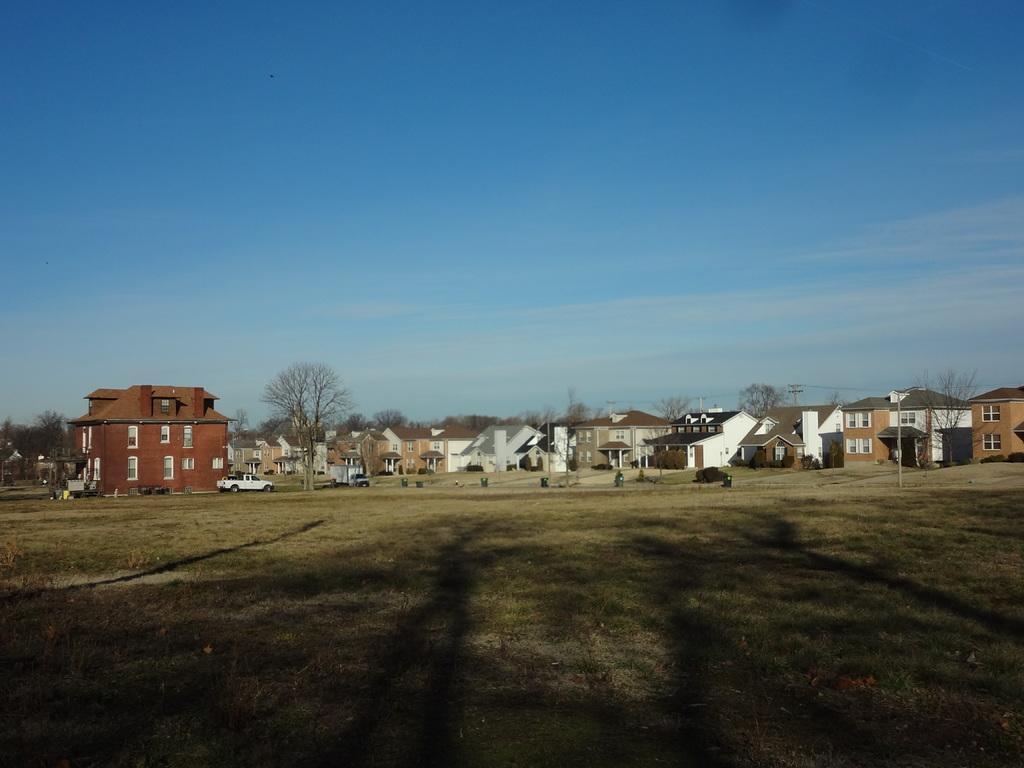Could you give a brief overview of what you see in this image? In this image there are a few cars and other vehicles on the roads, behind that there are trees and buildings and there are electrical cables on top of the poles, on the surface there is grass, in the sky there are clouds. 